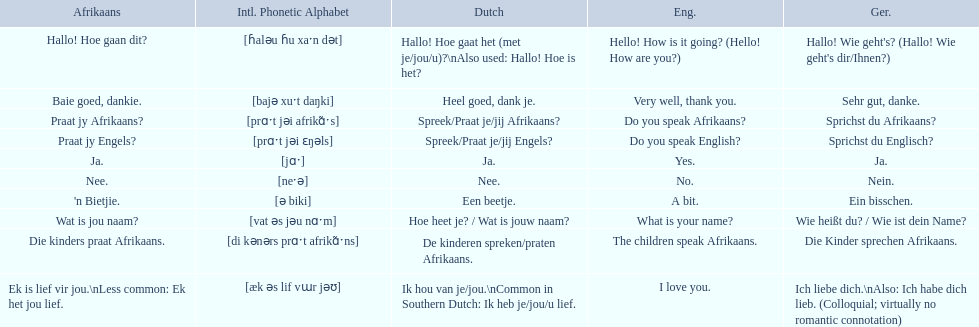Translate the following into german: die kinders praat afrikaans. Die Kinder sprechen Afrikaans. 